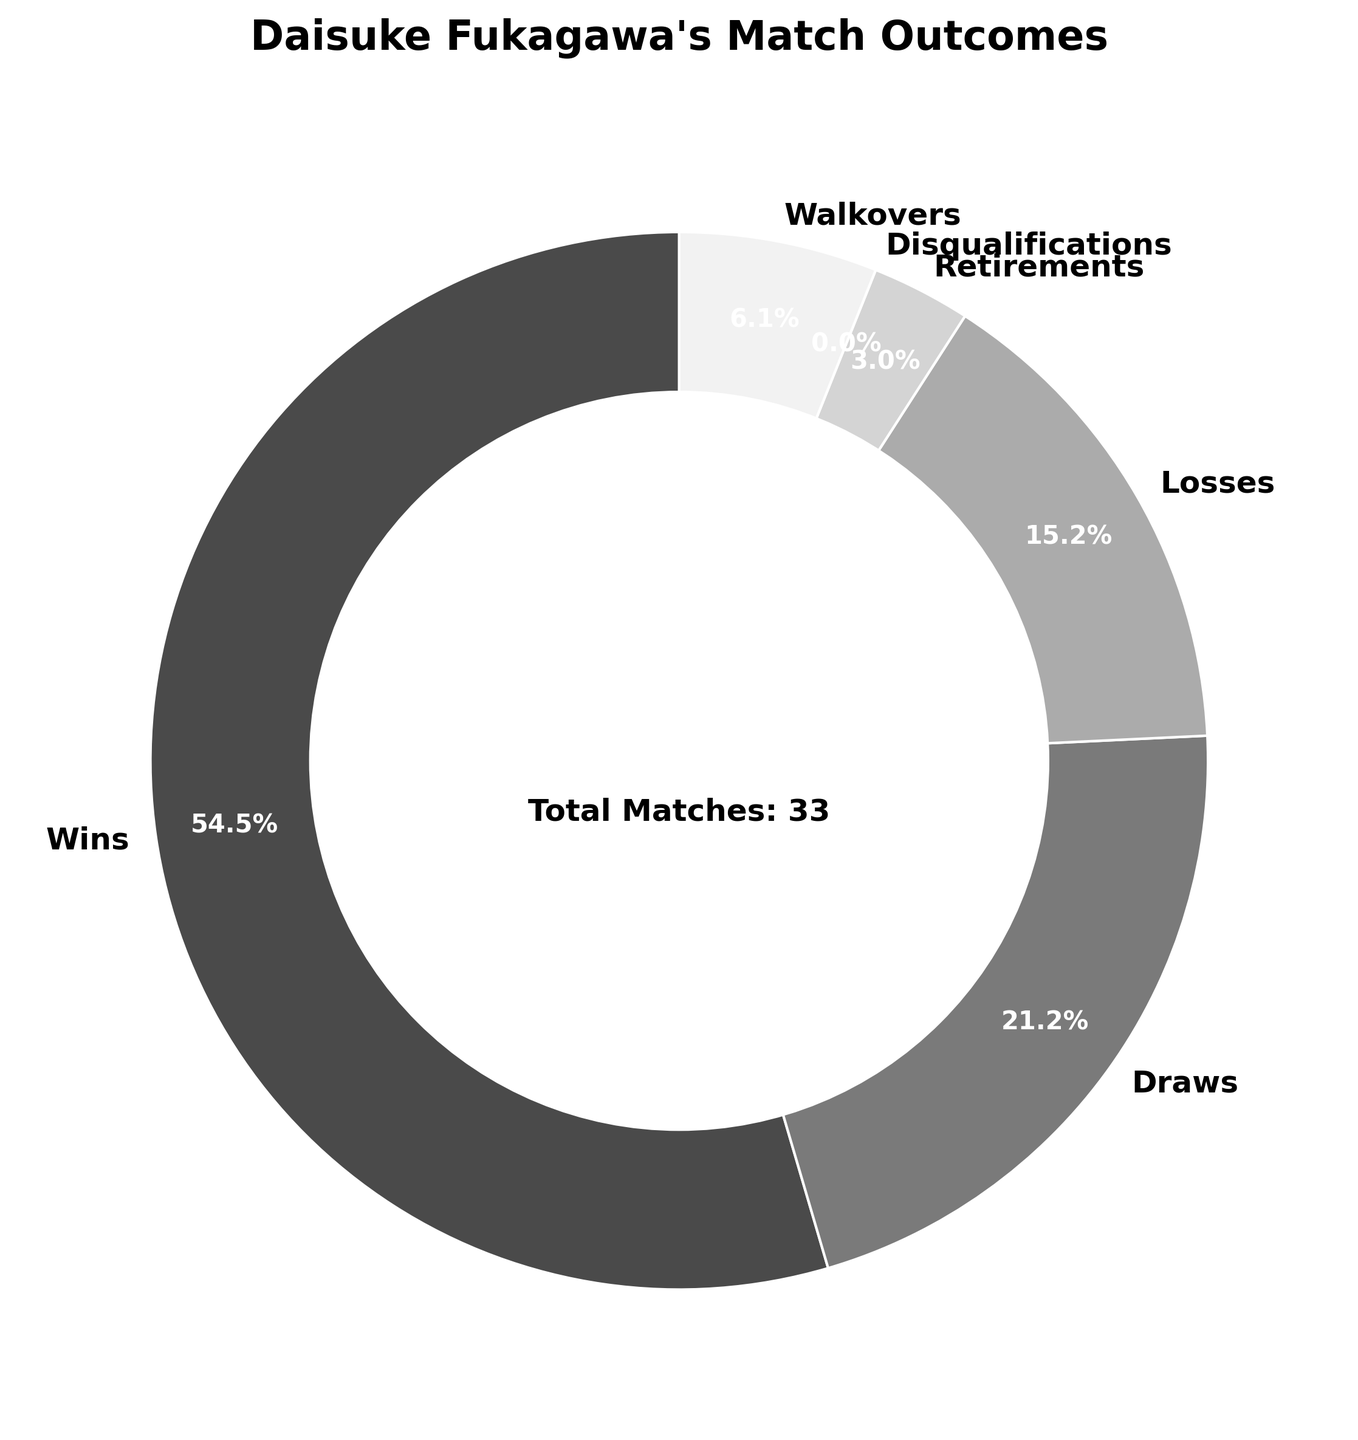What percentage of Daisuke Fukagawa's matches resulted in wins? Look at the pie chart and find the section labeled "Wins". The percentage figure usually displayed in that section represents the wins.
Answer: 60.0% How many more wins were there compared to losses? Find the number of wins and losses from the pie chart. Subtract the number of losses (5) from wins (18).
Answer: 13 Between draws, losses, and walkovers, which had the highest percentage? Compare the percentage figures for draws, losses, and walkovers on the pie chart. Draws have 23.3%, losses have 16.7%, and walkovers have 6.7%.
Answer: Draws What is the combined percentage of matches that ended in disqualifications and retirements? Find the percentage figures for disqualifications (0%) and retirements (3.3%). Add these two percentages together.
Answer: 3.3% What is the difference in the number of matches between draws and walkovers? Find the number of matches that ended in draws (7) and walkovers (2). Subtract the number of walkovers from draws.
Answer: 5 What is the total number of matches played by Daisuke Fukagawa last season? Look for the annotation mentioning "Total Matches". This number represents the sum of all matches across different outcomes.
Answer: 33 Which outcome category has the smallest number of matches? Refer to the pie chart sections and their labels for the smallest segment. The section for disqualifications typically has 0 matches.
Answer: Disqualifications How many matches ended without a clear win or loss (draws, walkovers, retirements, and disqualifications combined)? Find the number of matches for draws (7), walkovers (2), retirements (1), and disqualifications (0). Sum these values together.
Answer: 10 